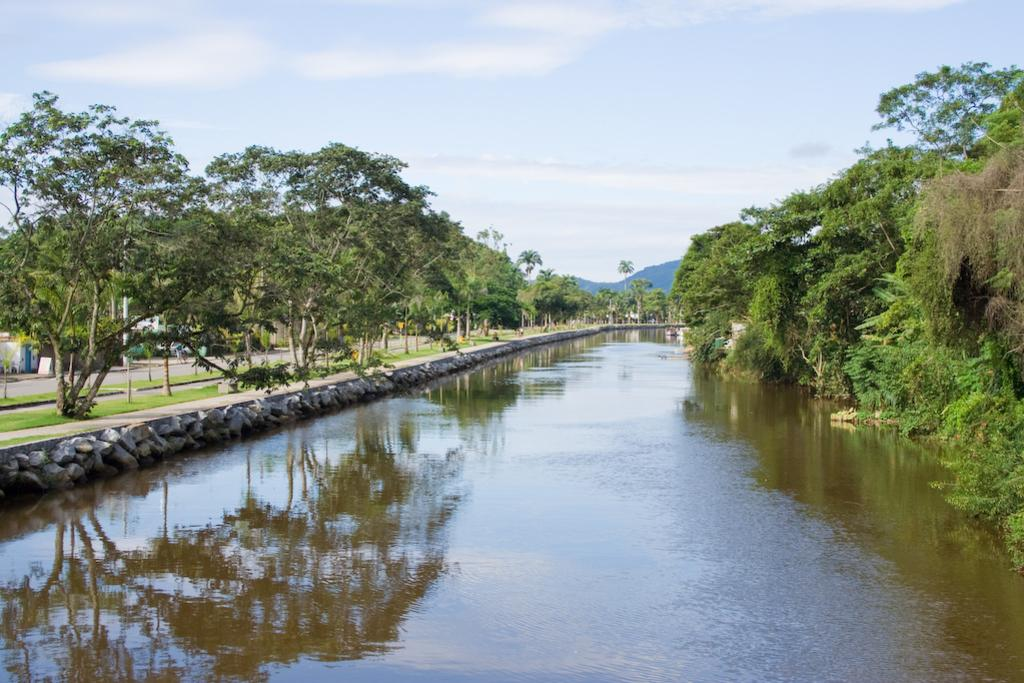What is the main feature of the image? The main feature of the image is water. What can be seen near the water? There are many trees and a road near the water. What is visible in the background of the image? In the background, there are mountains, clouds in the sky, and the sky itself. What color is the news in the image? There is no news present in the image, so it cannot be assigned a color. 